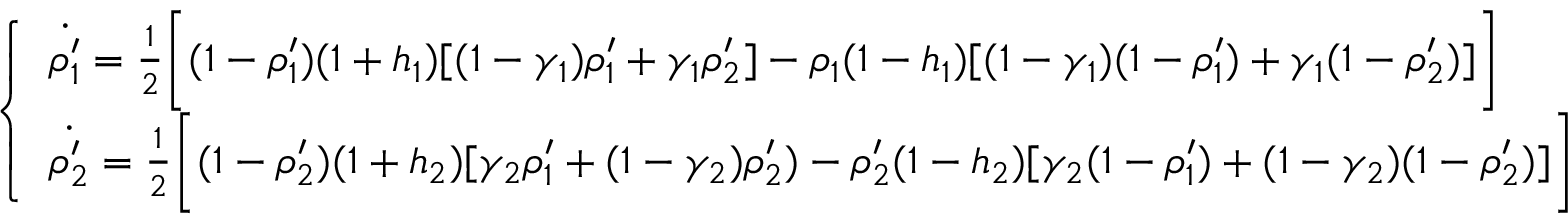Convert formula to latex. <formula><loc_0><loc_0><loc_500><loc_500>\left \{ \begin{array} { l l } { \dot { \rho _ { 1 } ^ { \prime } } = \frac { 1 } { 2 } \left [ ( 1 - \rho _ { 1 } ^ { \prime } ) ( 1 + h _ { 1 } ) [ ( 1 - \gamma _ { 1 } ) \rho _ { 1 } ^ { \prime } + \gamma _ { 1 } \rho _ { 2 } ^ { \prime } ] - \rho _ { 1 } ( 1 - h _ { 1 } ) [ ( 1 - \gamma _ { 1 } ) ( 1 - \rho _ { 1 } ^ { \prime } ) + \gamma _ { 1 } ( 1 - \rho _ { 2 } ^ { \prime } ) ] \right ] } \\ { \dot { \rho _ { 2 } ^ { \prime } } = \frac { 1 } { 2 } \left [ ( 1 - \rho _ { 2 } ^ { \prime } ) ( 1 + h _ { 2 } ) [ \gamma _ { 2 } \rho _ { 1 } ^ { \prime } + ( 1 - \gamma _ { 2 } ) \rho _ { 2 } ^ { \prime } ) - \rho _ { 2 } ^ { \prime } ( 1 - h _ { 2 } ) [ \gamma _ { 2 } ( 1 - \rho _ { 1 } ^ { \prime } ) + ( 1 - \gamma _ { 2 } ) ( 1 - \rho _ { 2 } ^ { \prime } ) ] \right ] } \end{array}</formula> 